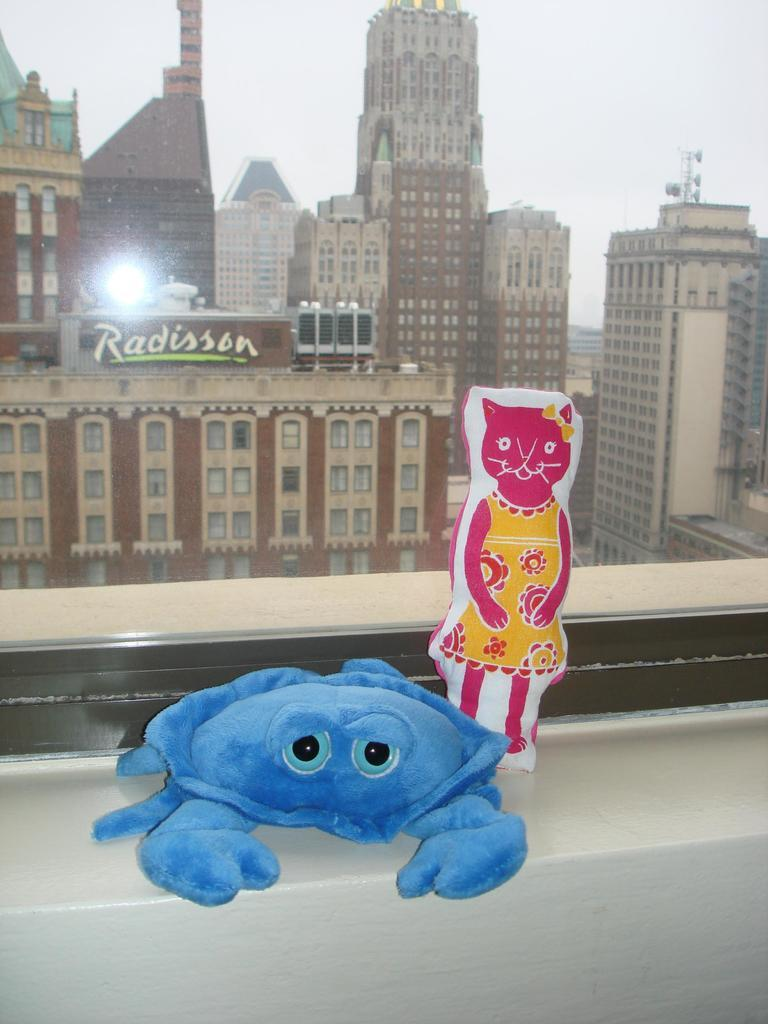How many toys are visible in the image? There are two toys in the image. What colors are the toys? One toy is pink, and the other is blue. Where are the toys located in the image? The toys are placed on a wall. What can be seen in the background of the image? There are buildings in the background of the image. Which actor is performing on the wall in the image? There are no actors or performances present in the image; it features two toys placed on a wall. 